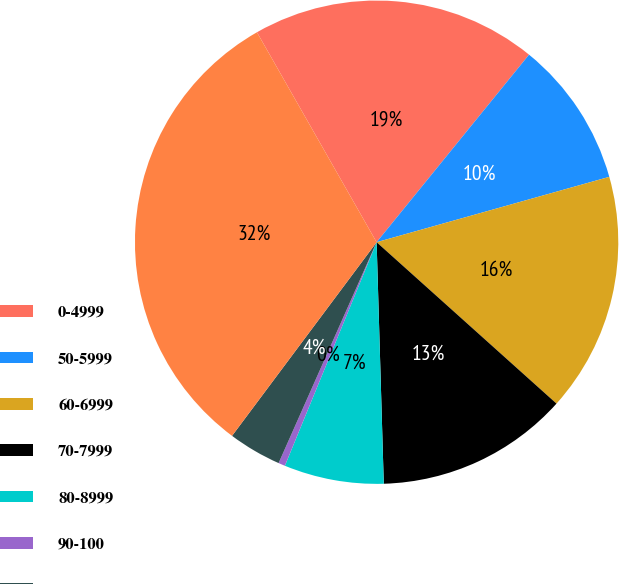<chart> <loc_0><loc_0><loc_500><loc_500><pie_chart><fcel>0-4999<fcel>50-5999<fcel>60-6999<fcel>70-7999<fcel>80-8999<fcel>90-100<fcel>Greater than 100<fcel>Total commercial and<nl><fcel>19.11%<fcel>9.78%<fcel>16.0%<fcel>12.89%<fcel>6.67%<fcel>0.45%<fcel>3.56%<fcel>31.55%<nl></chart> 